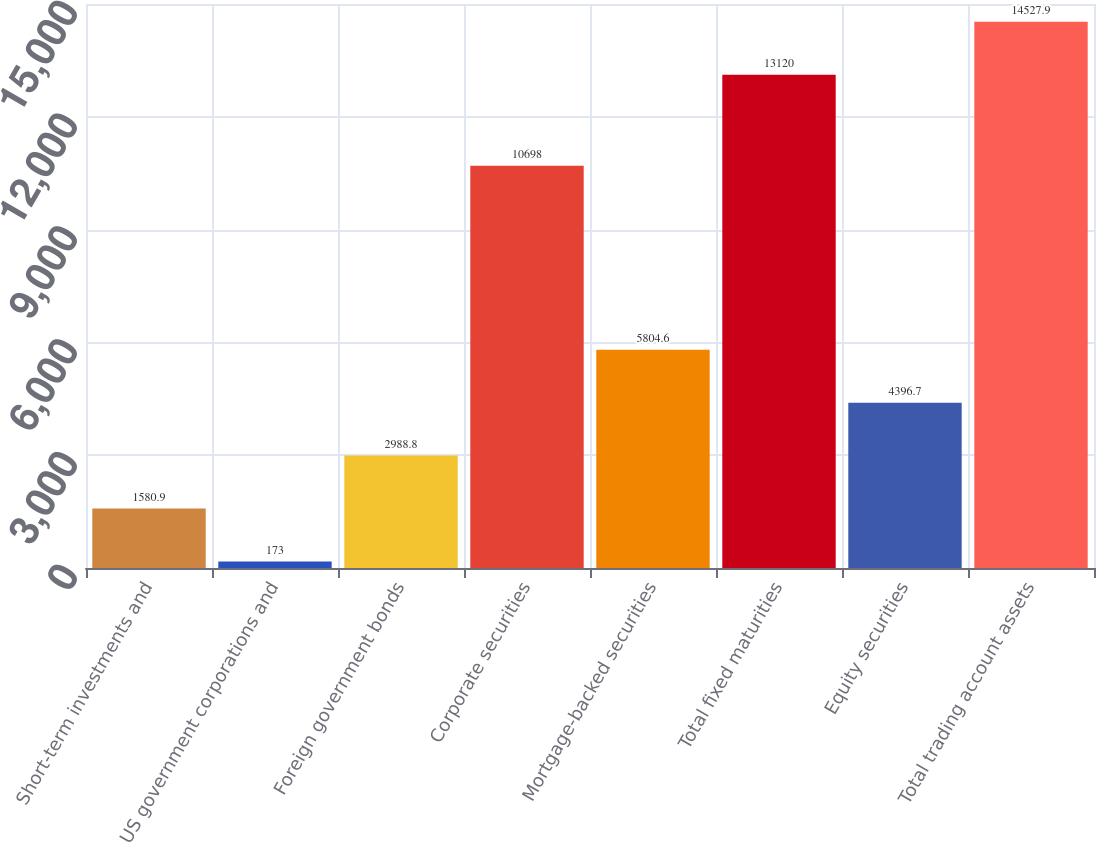Convert chart. <chart><loc_0><loc_0><loc_500><loc_500><bar_chart><fcel>Short-term investments and<fcel>US government corporations and<fcel>Foreign government bonds<fcel>Corporate securities<fcel>Mortgage-backed securities<fcel>Total fixed maturities<fcel>Equity securities<fcel>Total trading account assets<nl><fcel>1580.9<fcel>173<fcel>2988.8<fcel>10698<fcel>5804.6<fcel>13120<fcel>4396.7<fcel>14527.9<nl></chart> 